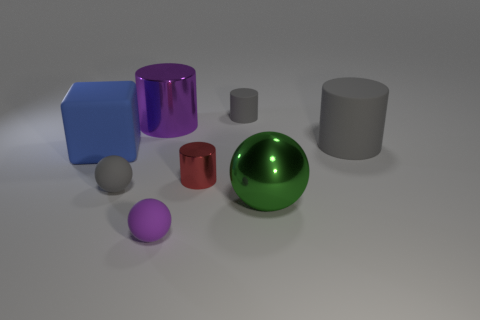Is the shape of the large purple object the same as the big blue matte object?
Keep it short and to the point. No. Are there any other things that have the same shape as the blue rubber object?
Give a very brief answer. No. Is the material of the purple object that is behind the tiny gray matte sphere the same as the large gray cylinder?
Offer a terse response. No. What shape is the big thing that is both right of the large purple metal thing and behind the blue matte block?
Your response must be concise. Cylinder. Are there any red cylinders that are behind the large rubber thing that is to the left of the purple sphere?
Offer a terse response. No. What number of other things are the same material as the green thing?
Keep it short and to the point. 2. There is a gray rubber thing behind the big metallic cylinder; is its shape the same as the large rubber thing that is behind the blue rubber block?
Ensure brevity in your answer.  Yes. Is the material of the cube the same as the tiny gray cylinder?
Give a very brief answer. Yes. How big is the gray matte cylinder behind the big cylinder that is right of the matte ball that is in front of the gray rubber sphere?
Make the answer very short. Small. How many other objects are there of the same color as the big metallic ball?
Provide a short and direct response. 0. 